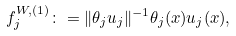Convert formula to latex. <formula><loc_0><loc_0><loc_500><loc_500>f _ { j } ^ { W , ( 1 ) } \colon = \| \theta _ { j } u _ { j } \| ^ { - 1 } \theta _ { j } ( x ) u _ { j } ( x ) ,</formula> 